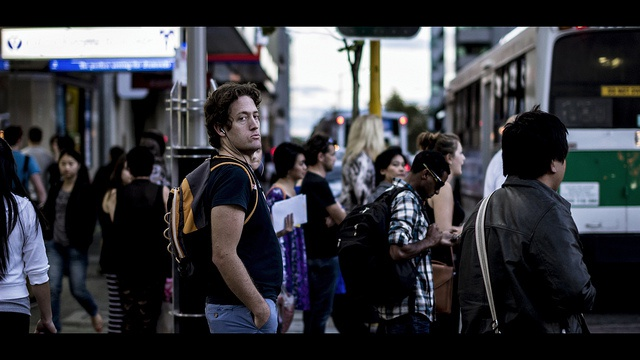Describe the objects in this image and their specific colors. I can see bus in black, gray, and darkgray tones, people in black, gray, and darkgray tones, people in black, gray, and navy tones, people in black, gray, and purple tones, and people in black, gray, and darkgray tones in this image. 